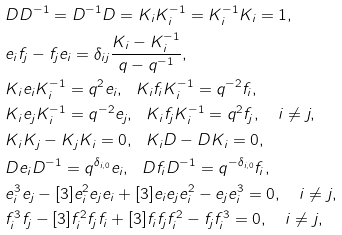Convert formula to latex. <formula><loc_0><loc_0><loc_500><loc_500>& D D ^ { - 1 } = D ^ { - 1 } D = K _ { i } K _ { i } ^ { - 1 } = K _ { i } ^ { - 1 } K _ { i } = 1 , \\ & e _ { i } f _ { j } - f _ { j } e _ { i } = \delta _ { i j } \frac { K _ { i } - K _ { i } ^ { - 1 } } { q - q ^ { - 1 } } , \\ & K _ { i } e _ { i } K _ { i } ^ { - 1 } = q ^ { 2 } e _ { i } , \ \ K _ { i } f _ { i } K _ { i } ^ { - 1 } = q ^ { - 2 } f _ { i } , \\ & K _ { i } e _ { j } K _ { i } ^ { - 1 } = q ^ { - 2 } e _ { j } , \ \ K _ { i } f _ { j } K _ { i } ^ { - 1 } = q ^ { 2 } f _ { j } , \quad i \neq j , \\ & K _ { i } K _ { j } - K _ { j } K _ { i } = 0 , \ \ K _ { i } D - D K _ { i } = 0 , \\ & D e _ { i } D ^ { - 1 } = q ^ { \delta _ { i , 0 } } e _ { i } , \ \ D f _ { i } D ^ { - 1 } = q ^ { - \delta _ { i , 0 } } f _ { i } , \\ & e _ { i } ^ { 3 } e _ { j } - [ 3 ] e _ { i } ^ { 2 } e _ { j } e _ { i } + [ 3 ] e _ { i } e _ { j } e _ { i } ^ { 2 } - e _ { j } e _ { i } ^ { 3 } = 0 , \quad i \neq j , \\ & f _ { i } ^ { 3 } f _ { j } - [ 3 ] f _ { i } ^ { 2 } f _ { j } f _ { i } + [ 3 ] f _ { i } f _ { j } f _ { i } ^ { 2 } - f _ { j } f _ { i } ^ { 3 } = 0 , \quad i \neq j , \\</formula> 